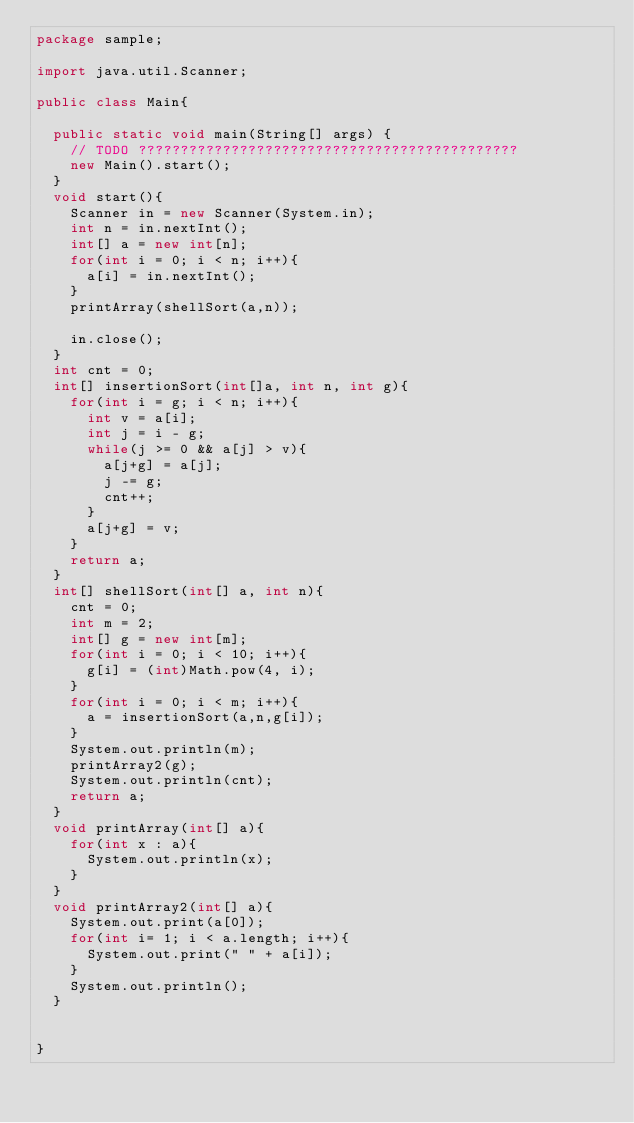<code> <loc_0><loc_0><loc_500><loc_500><_Java_>package sample;

import java.util.Scanner;

public class Main{

	public static void main(String[] args) {
		// TODO ?????????????????????????????????????????????
		new Main().start();
	}
	void start(){
		Scanner in = new Scanner(System.in);
		int n = in.nextInt();
		int[] a = new int[n];
		for(int i = 0; i < n; i++){
			a[i] = in.nextInt();
		}
		printArray(shellSort(a,n));
		
		in.close();
	}
	int cnt = 0;
	int[] insertionSort(int[]a, int n, int g){
		for(int i = g; i < n; i++){
			int v = a[i];
			int j = i - g;
			while(j >= 0 && a[j] > v){
				a[j+g] = a[j];
				j -= g;
				cnt++;
			}
			a[j+g] = v;
		}
		return a;
	}
	int[] shellSort(int[] a, int n){
		cnt = 0;
		int m = 2;
		int[] g = new int[m];
		for(int i = 0; i < 10; i++){
			g[i] = (int)Math.pow(4, i);
		}
		for(int i = 0; i < m; i++){
			a = insertionSort(a,n,g[i]);
		}
		System.out.println(m);
		printArray2(g);
		System.out.println(cnt);
		return a;
	}
	void printArray(int[] a){
		for(int x : a){
			System.out.println(x);
		}
	}
	void printArray2(int[] a){
		System.out.print(a[0]);
		for(int i= 1; i < a.length; i++){
			System.out.print(" " + a[i]);
		}
		System.out.println();
	}


}</code> 